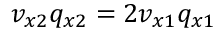Convert formula to latex. <formula><loc_0><loc_0><loc_500><loc_500>v _ { x 2 } q _ { x 2 } = 2 v _ { x 1 } q _ { x 1 }</formula> 